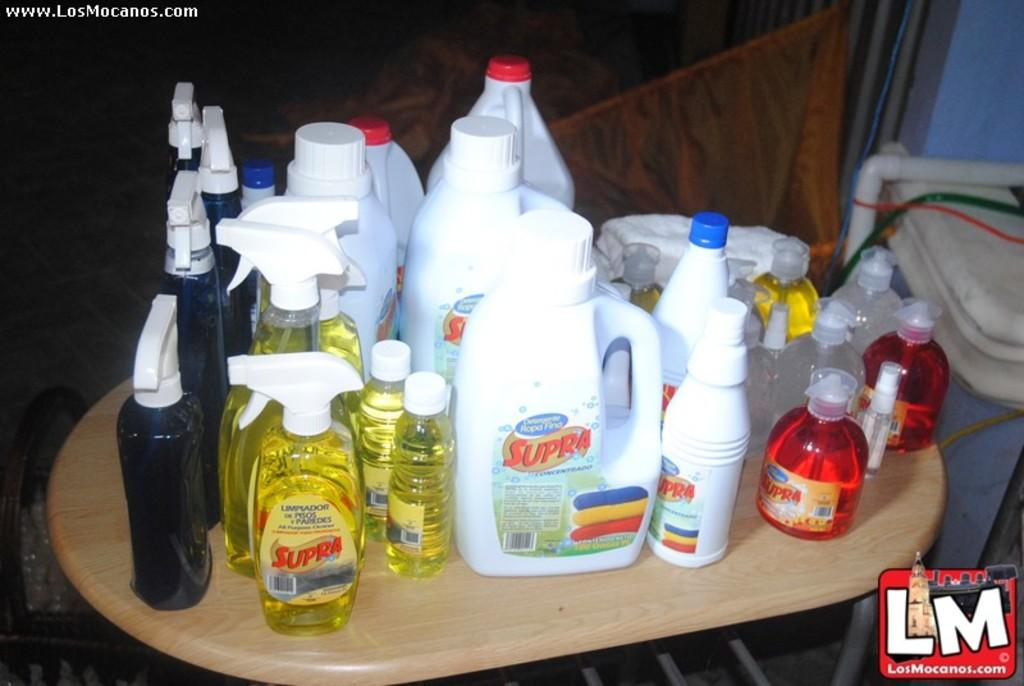What is the main piece of furniture in the image? There is a table in the image. What objects are on the table? There are bottles on the table. What can be seen on the right side of the image? There is a pipe on the right side of the image. What is visible in the background of the image? There is a wall, curtains, and a cloth in the background of the image. What type of slope can be seen in the image? There is no slope present in the image. How does the acoustics of the room affect the sound in the image? The image does not provide any information about the acoustics of the room, so it cannot be determined how they affect the sound. 